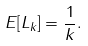Convert formula to latex. <formula><loc_0><loc_0><loc_500><loc_500>E [ L _ { k } ] = \frac { 1 } { k } .</formula> 